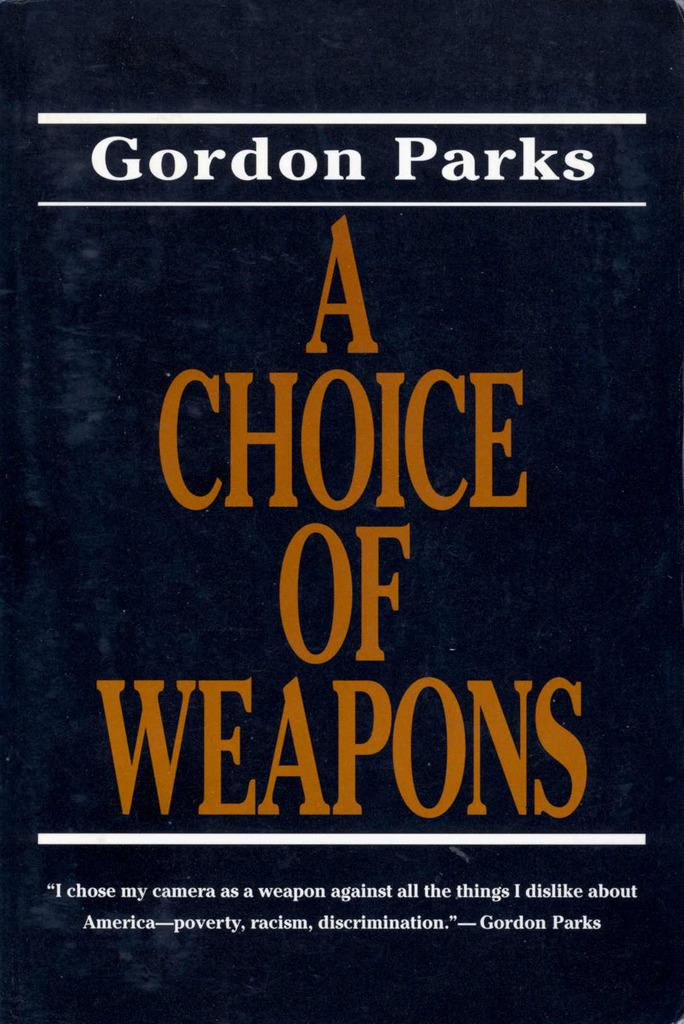<image>
Share a concise interpretation of the image provided. A book by Gordon Parks has a black cover. 